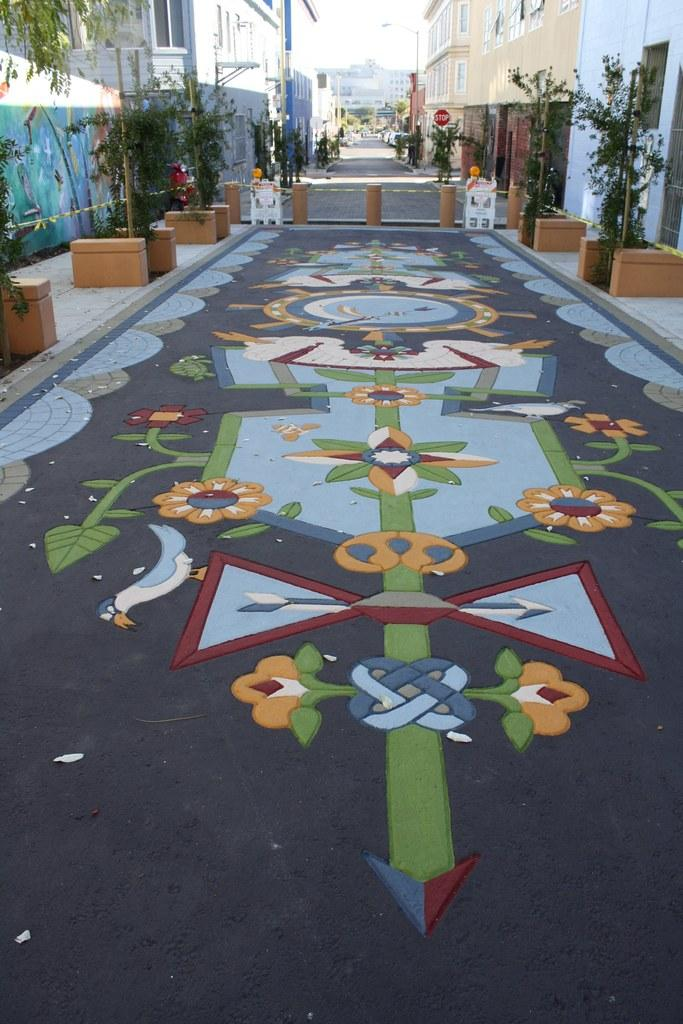What can be seen on the floor in the image? There is a design on the floor in the image. What else is present near the design on the floor? There are plants on either side of the design. What type of structures can be seen in the image? There are buildings visible in the image. Where is the robin perched in the image? There is no robin present in the image. What type of yoke is being used in the image? There is no yoke present in the image. 